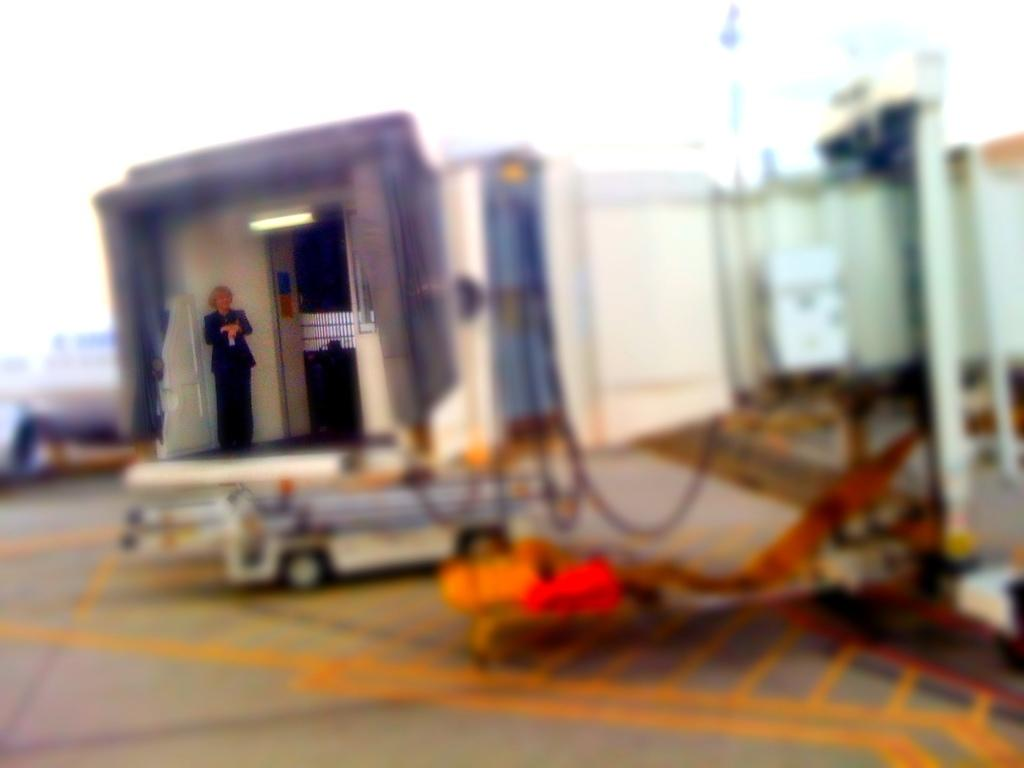What is the main subject of the image? The main subject of the image is a vehicle. Where is the vehicle located? The vehicle is on the road. Is there anyone on or near the vehicle? Yes, there is a person standing on the vehicle. What is the person wearing? The person is wearing a black color dress. What type of pleasure does the queen receive from the vehicle in the image? There is no queen present in the image, and therefore no pleasure can be attributed to her. 